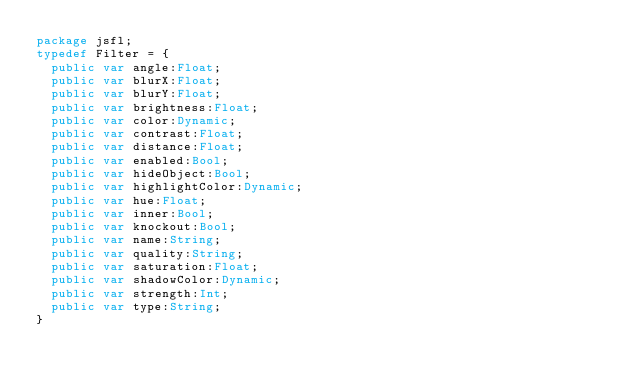<code> <loc_0><loc_0><loc_500><loc_500><_Haxe_>package jsfl;
typedef Filter = {
 	public var angle:Float;
	public var blurX:Float;
	public var blurY:Float;
	public var brightness:Float;
	public var color:Dynamic;
	public var contrast:Float;
	public var distance:Float;
	public var enabled:Bool;
	public var hideObject:Bool;
	public var highlightColor:Dynamic;
	public var hue:Float;
	public var inner:Bool;
	public var knockout:Bool;
	public var name:String;
	public var quality:String;
	public var saturation:Float;
	public var shadowColor:Dynamic;
	public var strength:Int;
	public var type:String;
}</code> 